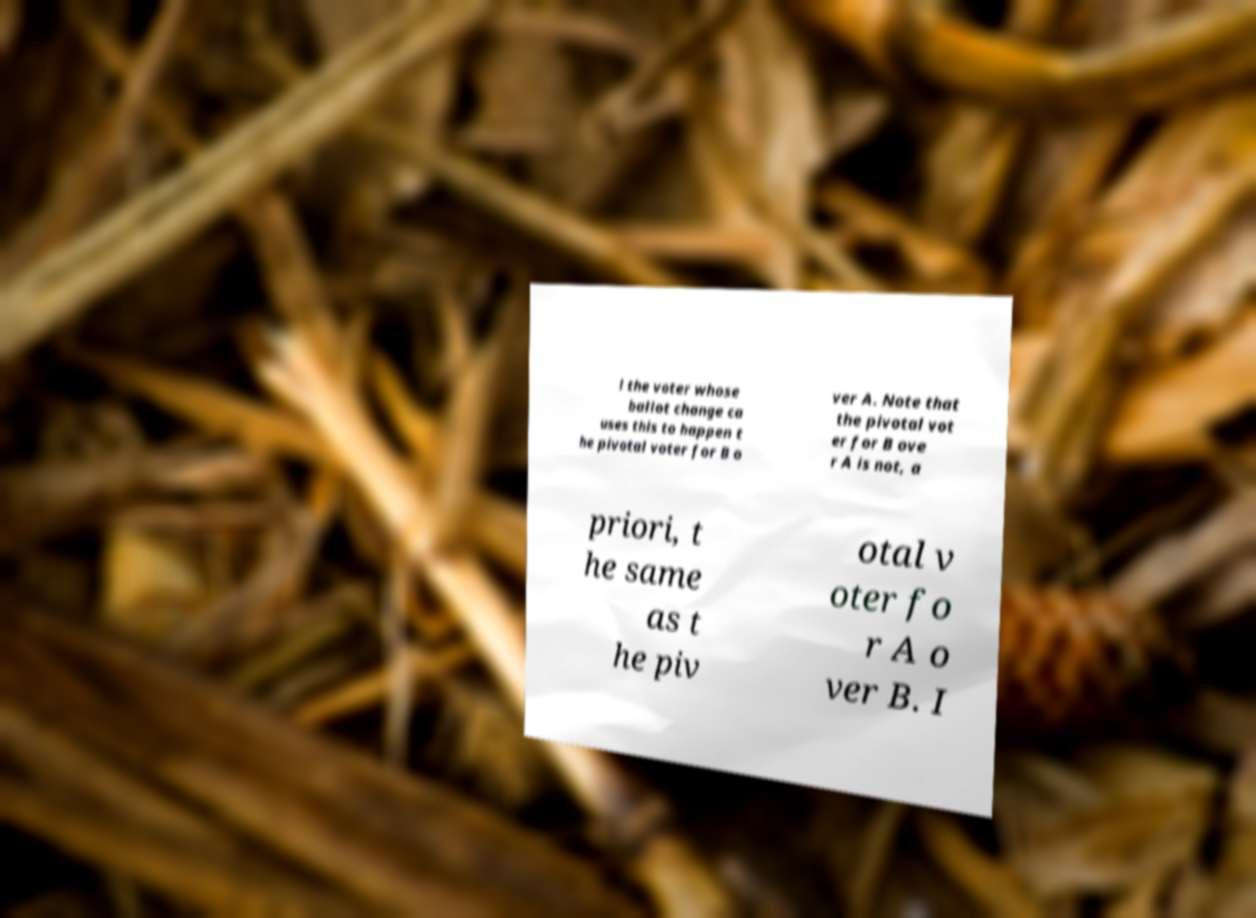Can you accurately transcribe the text from the provided image for me? l the voter whose ballot change ca uses this to happen t he pivotal voter for B o ver A. Note that the pivotal vot er for B ove r A is not, a priori, t he same as t he piv otal v oter fo r A o ver B. I 